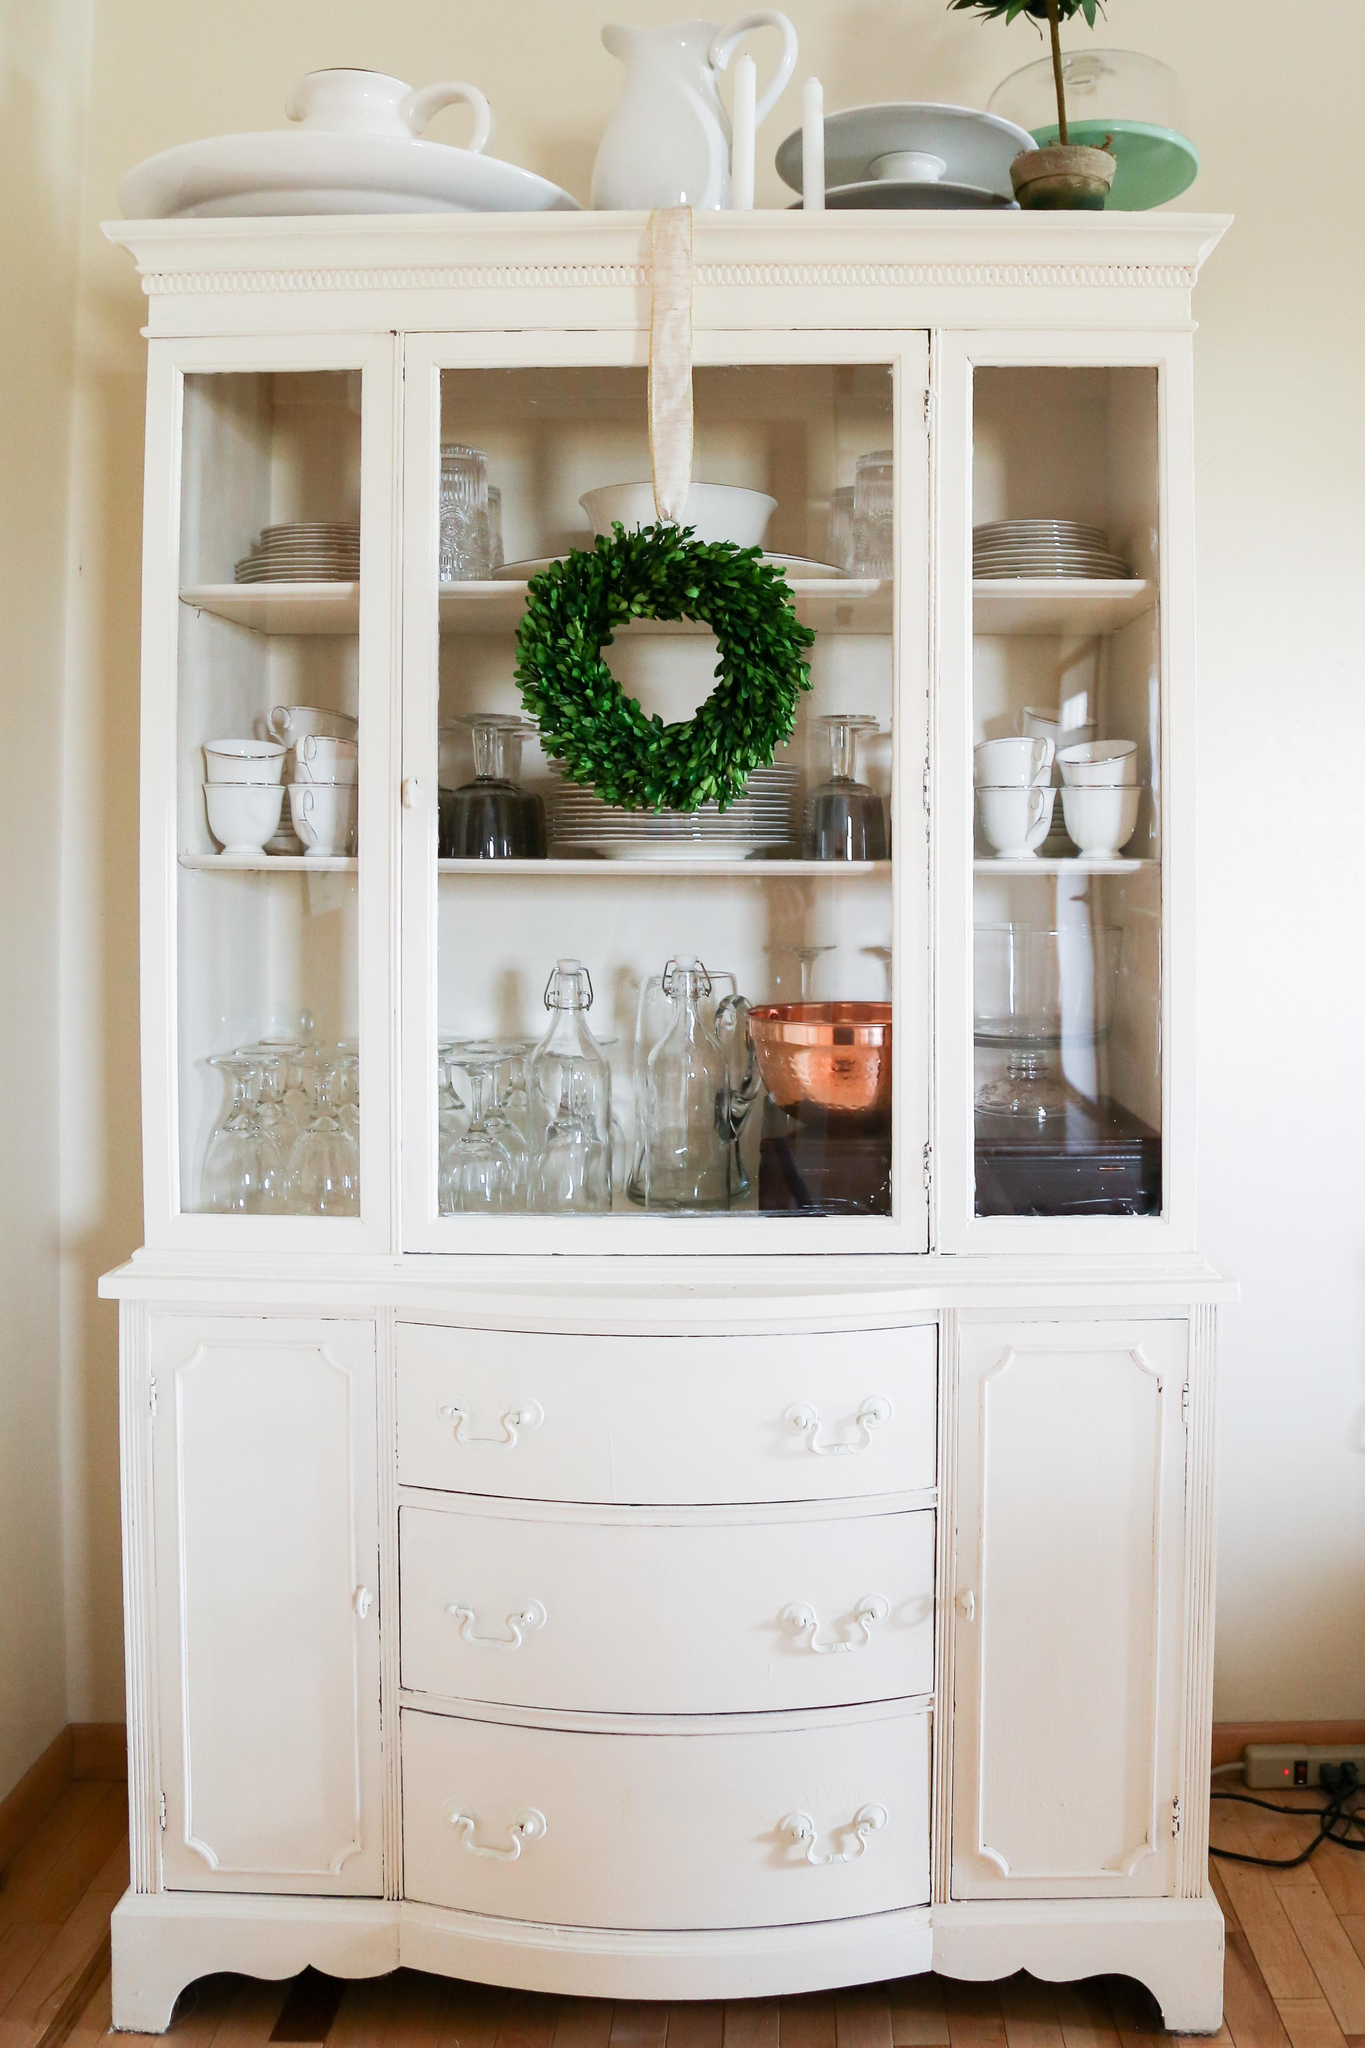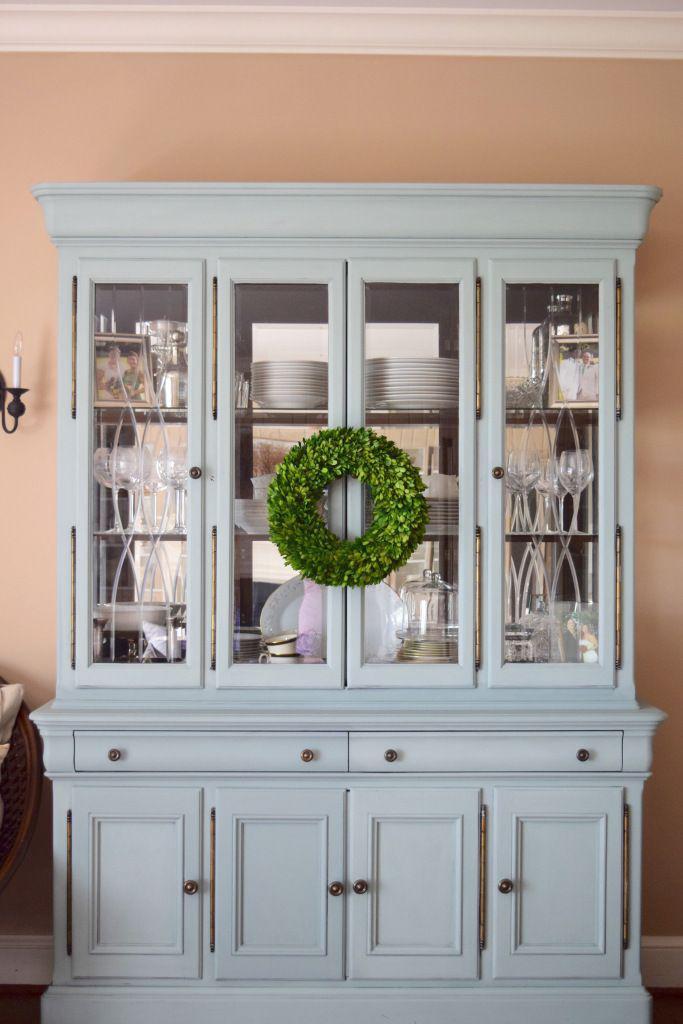The first image is the image on the left, the second image is the image on the right. Examine the images to the left and right. Is the description "One cabinet has a white exterior and a front that is not flat, with curving drawers under the display hutch top." accurate? Answer yes or no. Yes. The first image is the image on the left, the second image is the image on the right. Evaluate the accuracy of this statement regarding the images: "The cabinet in the image on the right is not a square shape.". Is it true? Answer yes or no. No. 